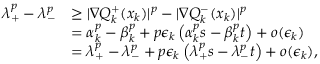<formula> <loc_0><loc_0><loc_500><loc_500>\begin{array} { r l } { \lambda _ { + } ^ { p } - \lambda _ { - } ^ { p } } & { \geq | \nabla Q _ { k } ^ { + } ( x _ { k } ) | ^ { p } - | \nabla Q _ { k } ^ { - } ( x _ { k } ) | ^ { p } } \\ & { = \alpha _ { k } ^ { p } - \beta _ { k } ^ { p } + p \epsilon _ { k } \left ( \alpha _ { k } ^ { p } s - \beta _ { k } ^ { p } t \right ) + o ( \epsilon _ { k } ) } \\ & { = \lambda _ { + } ^ { p } - \lambda _ { - } ^ { p } + p \epsilon _ { k } \left ( \lambda _ { + } ^ { p } s - \lambda _ { - } ^ { p } t \right ) + o ( \epsilon _ { k } ) , } \end{array}</formula> 